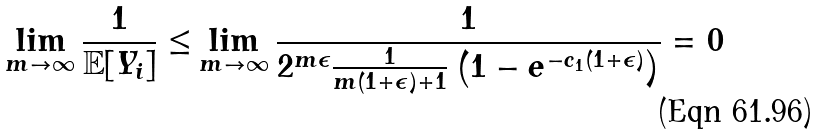<formula> <loc_0><loc_0><loc_500><loc_500>\lim _ { m \to \infty } \frac { 1 } { \mathbb { E } [ Y _ { i } ] } \leq & \lim _ { m \to \infty } \frac { 1 } { 2 ^ { m \epsilon } \frac { 1 } { m ( 1 + \epsilon ) + 1 } \left ( 1 - e ^ { - c _ { 1 } ( 1 + \epsilon ) } \right ) } = 0</formula> 